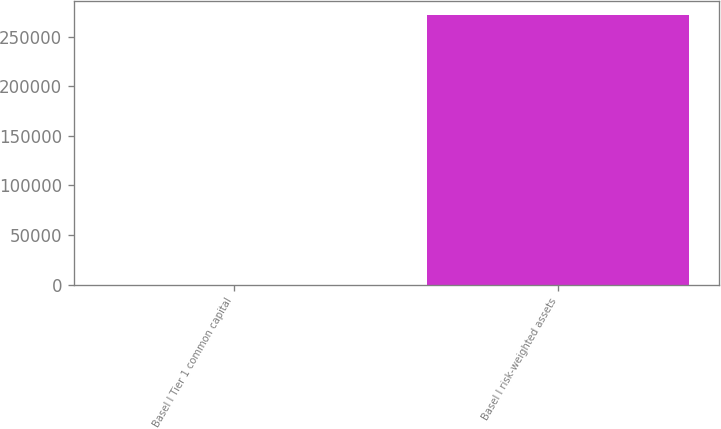Convert chart to OTSL. <chart><loc_0><loc_0><loc_500><loc_500><bar_chart><fcel>Basel I Tier 1 common capital<fcel>Basel I risk-weighted assets<nl><fcel>10.5<fcel>272169<nl></chart> 